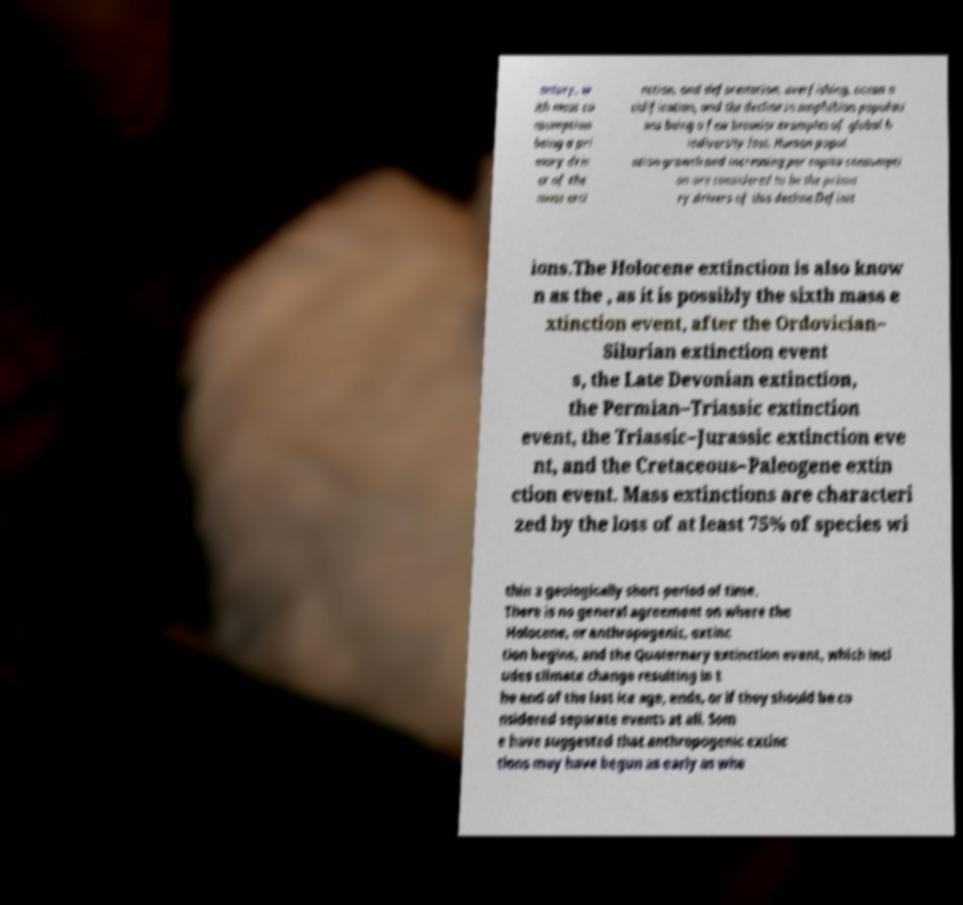Could you extract and type out the text from this image? entury, w ith meat co nsumption being a pri mary driv er of the mass exti nction, and deforestation, overfishing, ocean a cidification, and the decline in amphibian populati ons being a few broader examples of global b iodiversity loss. Human popul ation growth and increasing per capita consumpti on are considered to be the prima ry drivers of this decline.Definit ions.The Holocene extinction is also know n as the , as it is possibly the sixth mass e xtinction event, after the Ordovician– Silurian extinction event s, the Late Devonian extinction, the Permian–Triassic extinction event, the Triassic–Jurassic extinction eve nt, and the Cretaceous–Paleogene extin ction event. Mass extinctions are characteri zed by the loss of at least 75% of species wi thin a geologically short period of time. There is no general agreement on where the Holocene, or anthropogenic, extinc tion begins, and the Quaternary extinction event, which incl udes climate change resulting in t he end of the last ice age, ends, or if they should be co nsidered separate events at all. Som e have suggested that anthropogenic extinc tions may have begun as early as whe 